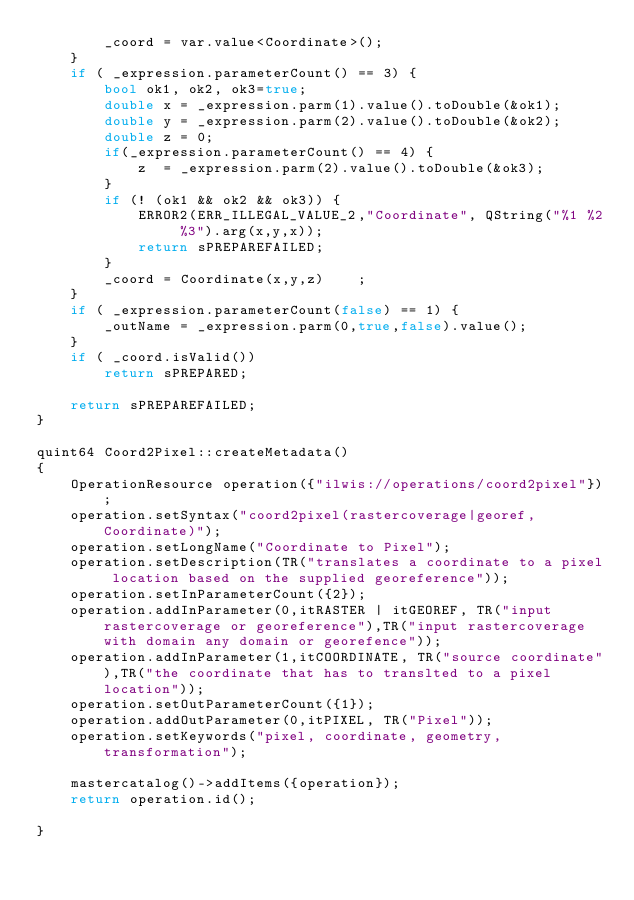Convert code to text. <code><loc_0><loc_0><loc_500><loc_500><_C++_>        _coord = var.value<Coordinate>();
    }
    if ( _expression.parameterCount() == 3) {
        bool ok1, ok2, ok3=true;
        double x = _expression.parm(1).value().toDouble(&ok1);
        double y = _expression.parm(2).value().toDouble(&ok2);
        double z = 0;
        if(_expression.parameterCount() == 4) {
            z  = _expression.parm(2).value().toDouble(&ok3);
        }
        if (! (ok1 && ok2 && ok3)) {
            ERROR2(ERR_ILLEGAL_VALUE_2,"Coordinate", QString("%1 %2 %3").arg(x,y,x));
            return sPREPAREFAILED;
        }
        _coord = Coordinate(x,y,z)    ;
    }
    if ( _expression.parameterCount(false) == 1) {
        _outName = _expression.parm(0,true,false).value();
    }
    if ( _coord.isValid())
        return sPREPARED;

    return sPREPAREFAILED;
}

quint64 Coord2Pixel::createMetadata()
{
    OperationResource operation({"ilwis://operations/coord2pixel"});
    operation.setSyntax("coord2pixel(rastercoverage|georef,Coordinate)");
    operation.setLongName("Coordinate to Pixel");
    operation.setDescription(TR("translates a coordinate to a pixel location based on the supplied georeference"));
    operation.setInParameterCount({2});
    operation.addInParameter(0,itRASTER | itGEOREF, TR("input rastercoverage or georeference"),TR("input rastercoverage with domain any domain or georefence"));
    operation.addInParameter(1,itCOORDINATE, TR("source coordinate"),TR("the coordinate that has to translted to a pixel location"));
    operation.setOutParameterCount({1});
    operation.addOutParameter(0,itPIXEL, TR("Pixel"));
    operation.setKeywords("pixel, coordinate, geometry,transformation");

    mastercatalog()->addItems({operation});
    return operation.id();

}
</code> 